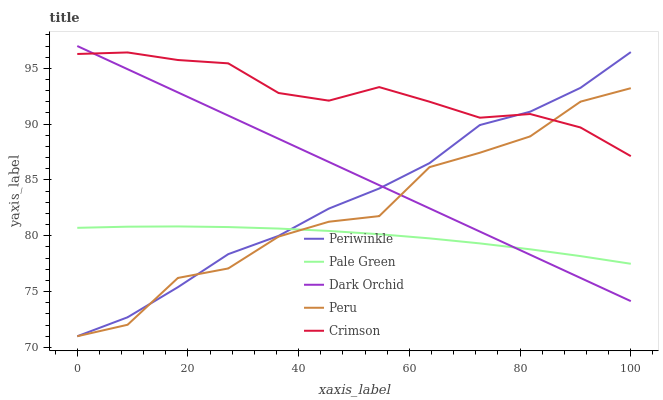Does Pale Green have the minimum area under the curve?
Answer yes or no. Yes. Does Crimson have the maximum area under the curve?
Answer yes or no. Yes. Does Periwinkle have the minimum area under the curve?
Answer yes or no. No. Does Periwinkle have the maximum area under the curve?
Answer yes or no. No. Is Dark Orchid the smoothest?
Answer yes or no. Yes. Is Peru the roughest?
Answer yes or no. Yes. Is Pale Green the smoothest?
Answer yes or no. No. Is Pale Green the roughest?
Answer yes or no. No. Does Pale Green have the lowest value?
Answer yes or no. No. Does Periwinkle have the highest value?
Answer yes or no. No. Is Pale Green less than Crimson?
Answer yes or no. Yes. Is Crimson greater than Pale Green?
Answer yes or no. Yes. Does Pale Green intersect Crimson?
Answer yes or no. No. 